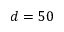<formula> <loc_0><loc_0><loc_500><loc_500>d = 5 0</formula> 